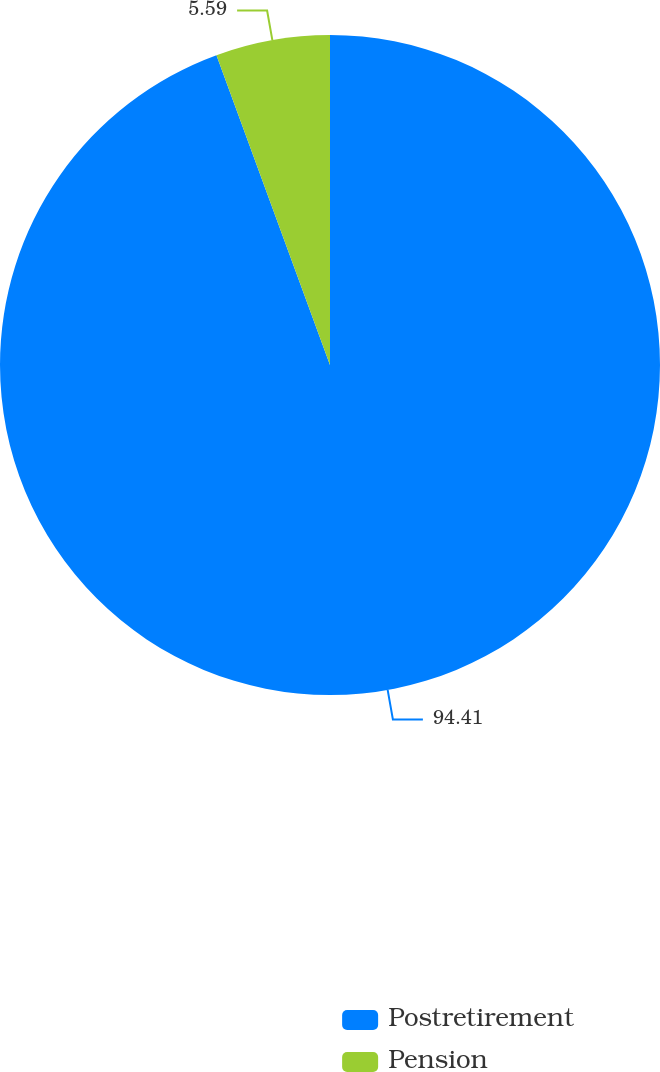Convert chart. <chart><loc_0><loc_0><loc_500><loc_500><pie_chart><fcel>Postretirement<fcel>Pension<nl><fcel>94.41%<fcel>5.59%<nl></chart> 